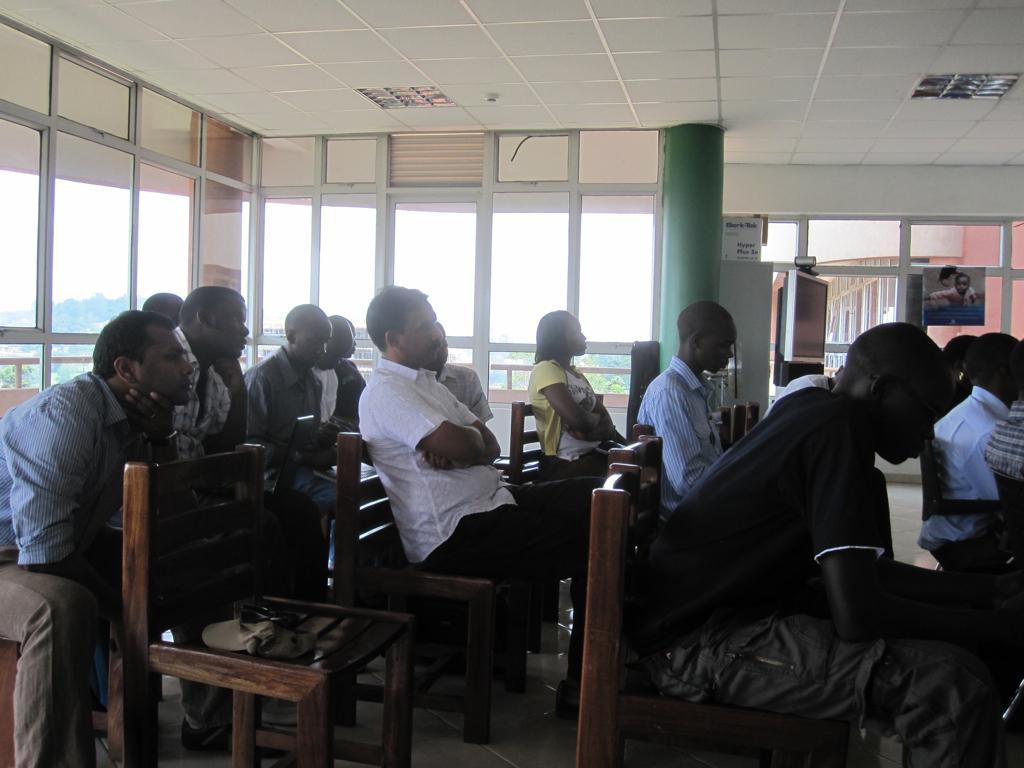Please provide a concise description of this image. This image is clicked inside. There are group of people sitting on a wooden chairs. On the top right there is a poster of a Boy. There is a Television which is attached to the stand and a green color pillar. In the background we can see the outside view which includes trees, plants and a sunny day. 